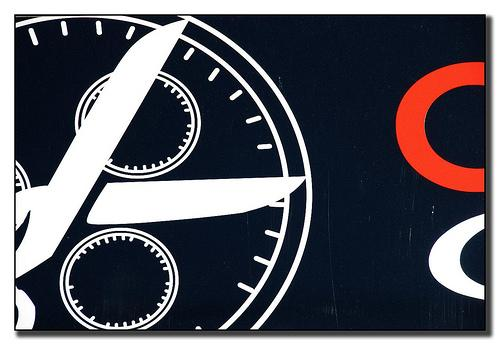Identify the primary object and investigate its role as a representation of a concept or theme. The primary object is a pair of open white scissors, which seem to symbolize the concept of time, as they interact with a clock-like structure containing tick marks and lines. Characterize the primary object in the image and discuss its features. The main object is a pair of white scissors, which are open and occupy most of the image. They have a shadow effect, sharp edges, and they are situated over a circular background with tick marks and lines. Examine the main object's interaction with other objects or elements in the image. The open scissors appear to be cutting or replacing the hands of a symbolic timepiece or clock, as they intersect with white tick marks and lines in a circular pattern. Describe the role of lines and circles in the composition of the picture. Lines and circles in the image create a structure that resembles a clock or gauge, where the open white scissors seem to play the role of clock hands or indicators. In your own words, recount the primary figures in the image and their contributions to the overall visual aesthetics. The main figures are the open white scissors with shadow effects and sharp edges. They contribute to the visual aesthetics by contrasting against the dark background and interacting with intricate circular elements, forming a harmonious and symbolic composition. In simple terms, describe the central subject of the image and its surroundings. The image shows open white scissors with a black background and white circles, tick marks, and lines forming gauges or a dial. Evaluate the sense of depth in the image by mentioning the main subject and its connection to the background. The white open scissors create a sense of depth through the shadow effect on them, and their interaction with the black background and circular elements like tick marks and lines. What is the most distinctive visual element in the image? The most distinctive element is the pair of white, open scissors with sharp edges, which contrast against the black background and the circular graphic elements. Is there any object with a different color than the rest in the image? If so, describe it. Yes, there is a bright red half-circle contrasting with the mostly white and black elements in the image. What is the most striking feature of the main object in the picture? The most striking feature of the main white scissors object is their sharp, pointed edges and their contrasting appearance against the dark background and circular elements. Can you find the blue scissors in the image? There is no mention of blue scissors in the image, only white scissors are mentioned. Is there an image of a clock with all its hands and numbers visible? No, it's not mentioned in the image. Can you find a square-shaped object in the image? All the described objects are either circular, oval, or have curved edges. There is no mention of a square-shaped object. 